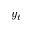<formula> <loc_0><loc_0><loc_500><loc_500>y _ { t }</formula> 